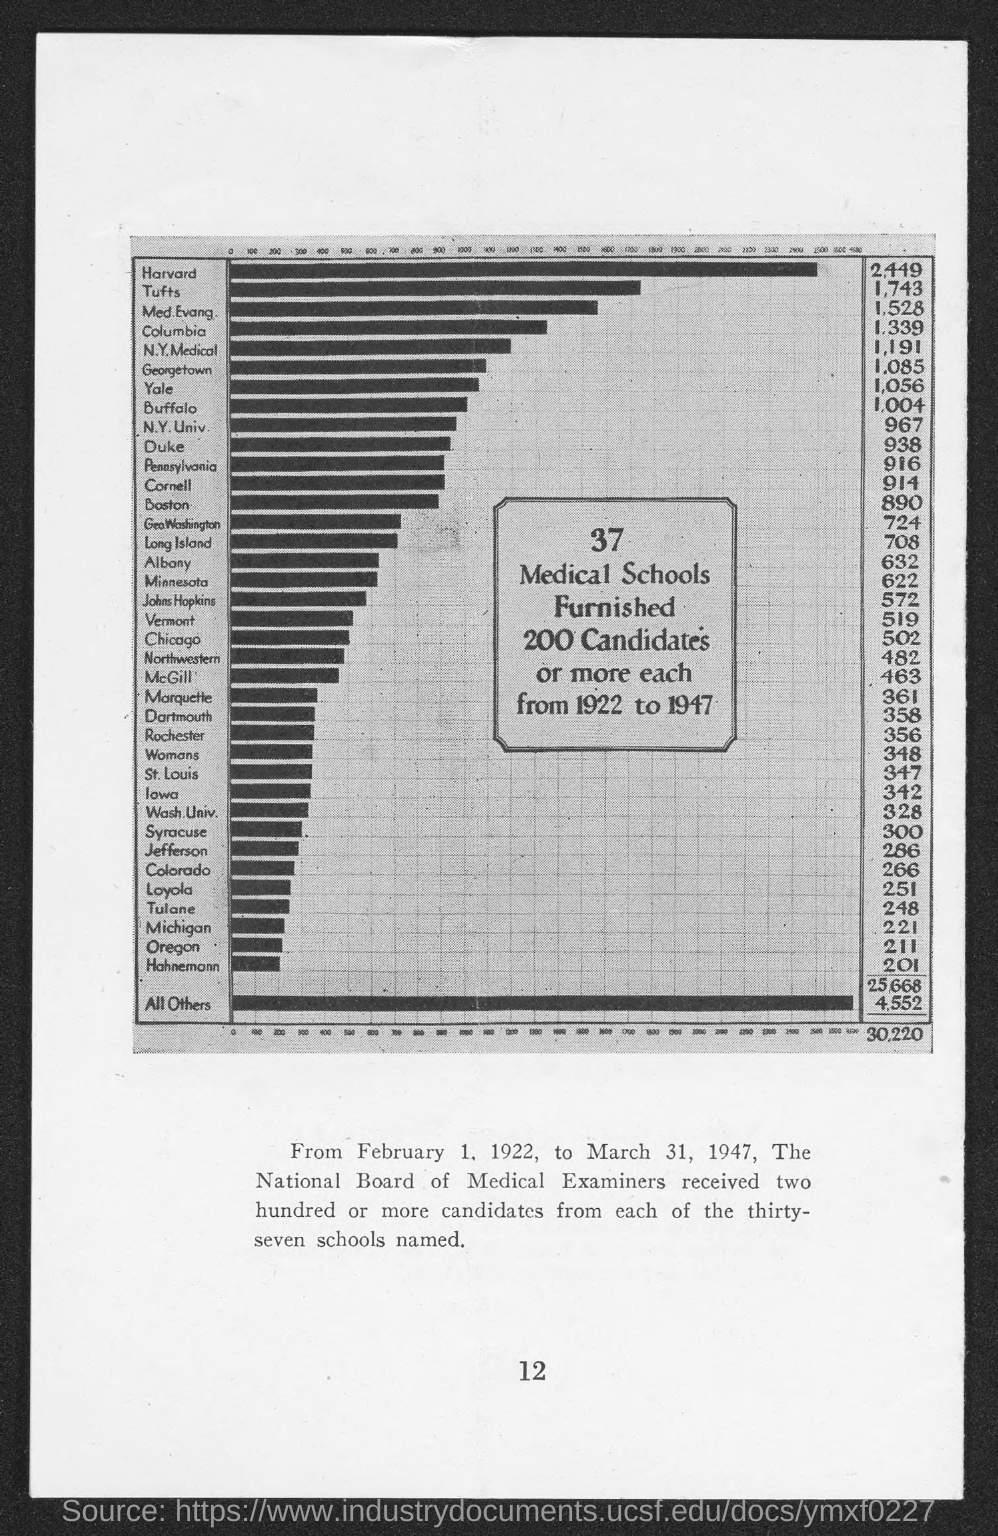What is the number at bottom of the page ?
Provide a succinct answer. 12. 